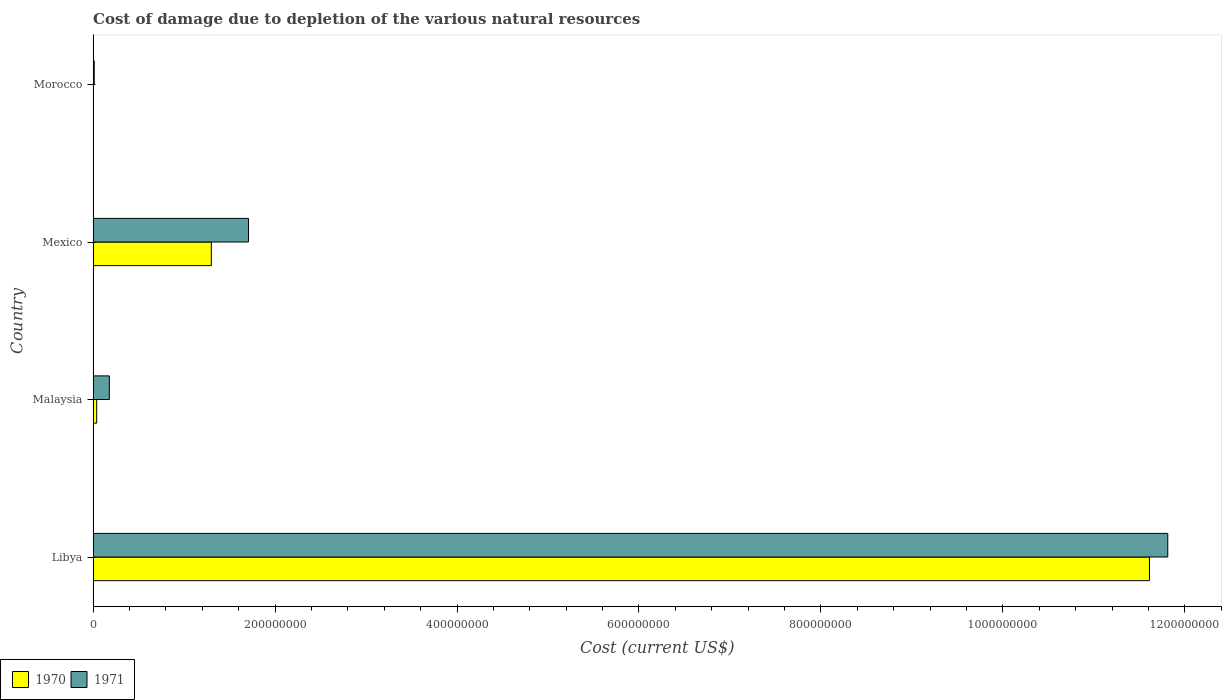How many different coloured bars are there?
Your answer should be very brief. 2. How many groups of bars are there?
Offer a terse response. 4. Are the number of bars per tick equal to the number of legend labels?
Your answer should be compact. Yes. Are the number of bars on each tick of the Y-axis equal?
Offer a very short reply. Yes. How many bars are there on the 3rd tick from the top?
Offer a very short reply. 2. What is the label of the 4th group of bars from the top?
Ensure brevity in your answer.  Libya. What is the cost of damage caused due to the depletion of various natural resources in 1970 in Morocco?
Your answer should be very brief. 3.51e+05. Across all countries, what is the maximum cost of damage caused due to the depletion of various natural resources in 1971?
Your answer should be compact. 1.18e+09. Across all countries, what is the minimum cost of damage caused due to the depletion of various natural resources in 1970?
Give a very brief answer. 3.51e+05. In which country was the cost of damage caused due to the depletion of various natural resources in 1970 maximum?
Keep it short and to the point. Libya. In which country was the cost of damage caused due to the depletion of various natural resources in 1970 minimum?
Ensure brevity in your answer.  Morocco. What is the total cost of damage caused due to the depletion of various natural resources in 1970 in the graph?
Your answer should be compact. 1.30e+09. What is the difference between the cost of damage caused due to the depletion of various natural resources in 1971 in Malaysia and that in Mexico?
Your answer should be compact. -1.53e+08. What is the difference between the cost of damage caused due to the depletion of various natural resources in 1971 in Mexico and the cost of damage caused due to the depletion of various natural resources in 1970 in Morocco?
Your response must be concise. 1.70e+08. What is the average cost of damage caused due to the depletion of various natural resources in 1971 per country?
Offer a very short reply. 3.43e+08. What is the difference between the cost of damage caused due to the depletion of various natural resources in 1970 and cost of damage caused due to the depletion of various natural resources in 1971 in Libya?
Offer a very short reply. -2.01e+07. In how many countries, is the cost of damage caused due to the depletion of various natural resources in 1971 greater than 1160000000 US$?
Your response must be concise. 1. What is the ratio of the cost of damage caused due to the depletion of various natural resources in 1970 in Libya to that in Mexico?
Provide a short and direct response. 8.93. Is the cost of damage caused due to the depletion of various natural resources in 1971 in Malaysia less than that in Morocco?
Give a very brief answer. No. What is the difference between the highest and the second highest cost of damage caused due to the depletion of various natural resources in 1971?
Provide a succinct answer. 1.01e+09. What is the difference between the highest and the lowest cost of damage caused due to the depletion of various natural resources in 1970?
Keep it short and to the point. 1.16e+09. In how many countries, is the cost of damage caused due to the depletion of various natural resources in 1970 greater than the average cost of damage caused due to the depletion of various natural resources in 1970 taken over all countries?
Your answer should be compact. 1. Is the sum of the cost of damage caused due to the depletion of various natural resources in 1971 in Libya and Malaysia greater than the maximum cost of damage caused due to the depletion of various natural resources in 1970 across all countries?
Provide a succinct answer. Yes. How many countries are there in the graph?
Offer a very short reply. 4. Are the values on the major ticks of X-axis written in scientific E-notation?
Make the answer very short. No. Where does the legend appear in the graph?
Offer a terse response. Bottom left. How are the legend labels stacked?
Make the answer very short. Horizontal. What is the title of the graph?
Make the answer very short. Cost of damage due to depletion of the various natural resources. Does "1994" appear as one of the legend labels in the graph?
Your answer should be very brief. No. What is the label or title of the X-axis?
Offer a very short reply. Cost (current US$). What is the Cost (current US$) of 1970 in Libya?
Ensure brevity in your answer.  1.16e+09. What is the Cost (current US$) of 1971 in Libya?
Offer a very short reply. 1.18e+09. What is the Cost (current US$) of 1970 in Malaysia?
Provide a succinct answer. 3.97e+06. What is the Cost (current US$) in 1971 in Malaysia?
Your answer should be very brief. 1.79e+07. What is the Cost (current US$) of 1970 in Mexico?
Make the answer very short. 1.30e+08. What is the Cost (current US$) in 1971 in Mexico?
Offer a very short reply. 1.71e+08. What is the Cost (current US$) in 1970 in Morocco?
Your response must be concise. 3.51e+05. What is the Cost (current US$) of 1971 in Morocco?
Give a very brief answer. 1.24e+06. Across all countries, what is the maximum Cost (current US$) of 1970?
Make the answer very short. 1.16e+09. Across all countries, what is the maximum Cost (current US$) of 1971?
Make the answer very short. 1.18e+09. Across all countries, what is the minimum Cost (current US$) of 1970?
Provide a short and direct response. 3.51e+05. Across all countries, what is the minimum Cost (current US$) in 1971?
Give a very brief answer. 1.24e+06. What is the total Cost (current US$) in 1970 in the graph?
Offer a terse response. 1.30e+09. What is the total Cost (current US$) in 1971 in the graph?
Offer a very short reply. 1.37e+09. What is the difference between the Cost (current US$) of 1970 in Libya and that in Malaysia?
Give a very brief answer. 1.16e+09. What is the difference between the Cost (current US$) of 1971 in Libya and that in Malaysia?
Provide a succinct answer. 1.16e+09. What is the difference between the Cost (current US$) of 1970 in Libya and that in Mexico?
Offer a very short reply. 1.03e+09. What is the difference between the Cost (current US$) in 1971 in Libya and that in Mexico?
Give a very brief answer. 1.01e+09. What is the difference between the Cost (current US$) in 1970 in Libya and that in Morocco?
Your answer should be very brief. 1.16e+09. What is the difference between the Cost (current US$) in 1971 in Libya and that in Morocco?
Give a very brief answer. 1.18e+09. What is the difference between the Cost (current US$) of 1970 in Malaysia and that in Mexico?
Give a very brief answer. -1.26e+08. What is the difference between the Cost (current US$) of 1971 in Malaysia and that in Mexico?
Provide a short and direct response. -1.53e+08. What is the difference between the Cost (current US$) in 1970 in Malaysia and that in Morocco?
Your answer should be compact. 3.62e+06. What is the difference between the Cost (current US$) in 1971 in Malaysia and that in Morocco?
Your response must be concise. 1.66e+07. What is the difference between the Cost (current US$) in 1970 in Mexico and that in Morocco?
Provide a short and direct response. 1.30e+08. What is the difference between the Cost (current US$) in 1971 in Mexico and that in Morocco?
Offer a terse response. 1.70e+08. What is the difference between the Cost (current US$) of 1970 in Libya and the Cost (current US$) of 1971 in Malaysia?
Your answer should be compact. 1.14e+09. What is the difference between the Cost (current US$) in 1970 in Libya and the Cost (current US$) in 1971 in Mexico?
Give a very brief answer. 9.90e+08. What is the difference between the Cost (current US$) in 1970 in Libya and the Cost (current US$) in 1971 in Morocco?
Your answer should be compact. 1.16e+09. What is the difference between the Cost (current US$) in 1970 in Malaysia and the Cost (current US$) in 1971 in Mexico?
Give a very brief answer. -1.67e+08. What is the difference between the Cost (current US$) of 1970 in Malaysia and the Cost (current US$) of 1971 in Morocco?
Your response must be concise. 2.73e+06. What is the difference between the Cost (current US$) in 1970 in Mexico and the Cost (current US$) in 1971 in Morocco?
Your answer should be very brief. 1.29e+08. What is the average Cost (current US$) in 1970 per country?
Give a very brief answer. 3.24e+08. What is the average Cost (current US$) of 1971 per country?
Offer a terse response. 3.43e+08. What is the difference between the Cost (current US$) of 1970 and Cost (current US$) of 1971 in Libya?
Ensure brevity in your answer.  -2.01e+07. What is the difference between the Cost (current US$) in 1970 and Cost (current US$) in 1971 in Malaysia?
Give a very brief answer. -1.39e+07. What is the difference between the Cost (current US$) in 1970 and Cost (current US$) in 1971 in Mexico?
Offer a very short reply. -4.08e+07. What is the difference between the Cost (current US$) in 1970 and Cost (current US$) in 1971 in Morocco?
Provide a short and direct response. -8.93e+05. What is the ratio of the Cost (current US$) in 1970 in Libya to that in Malaysia?
Your answer should be compact. 292.43. What is the ratio of the Cost (current US$) in 1971 in Libya to that in Malaysia?
Provide a succinct answer. 66.06. What is the ratio of the Cost (current US$) in 1970 in Libya to that in Mexico?
Your answer should be compact. 8.93. What is the ratio of the Cost (current US$) of 1971 in Libya to that in Mexico?
Provide a succinct answer. 6.92. What is the ratio of the Cost (current US$) of 1970 in Libya to that in Morocco?
Provide a short and direct response. 3303.64. What is the ratio of the Cost (current US$) of 1971 in Libya to that in Morocco?
Your response must be concise. 949.54. What is the ratio of the Cost (current US$) in 1970 in Malaysia to that in Mexico?
Keep it short and to the point. 0.03. What is the ratio of the Cost (current US$) of 1971 in Malaysia to that in Mexico?
Give a very brief answer. 0.1. What is the ratio of the Cost (current US$) in 1970 in Malaysia to that in Morocco?
Provide a short and direct response. 11.3. What is the ratio of the Cost (current US$) of 1971 in Malaysia to that in Morocco?
Give a very brief answer. 14.37. What is the ratio of the Cost (current US$) of 1970 in Mexico to that in Morocco?
Your answer should be very brief. 369.8. What is the ratio of the Cost (current US$) in 1971 in Mexico to that in Morocco?
Your response must be concise. 137.31. What is the difference between the highest and the second highest Cost (current US$) of 1970?
Your answer should be very brief. 1.03e+09. What is the difference between the highest and the second highest Cost (current US$) of 1971?
Keep it short and to the point. 1.01e+09. What is the difference between the highest and the lowest Cost (current US$) of 1970?
Your answer should be very brief. 1.16e+09. What is the difference between the highest and the lowest Cost (current US$) of 1971?
Offer a terse response. 1.18e+09. 